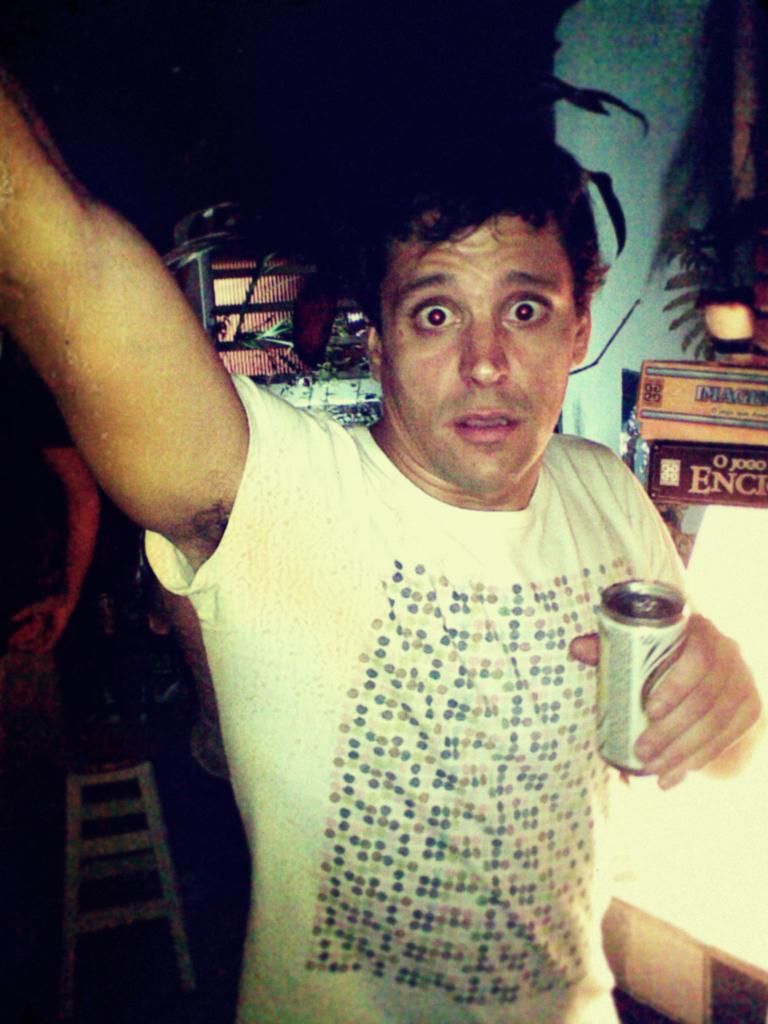What can be seen in the image? There is a person in the image. What is the person wearing? The person is wearing a white T-shirt. What is the person holding in their hand? The person is holding a tin in their hand. What object is on the left side of the image? There is a stool on the left side of the image. How would you describe the background of the image? The background of the image is dark. What type of quartz can be seen on the sofa in the image? There is no quartz or sofa present in the image. What type of wine is the person drinking in the image? There is no wine present in the image; the person is holding a tin. 